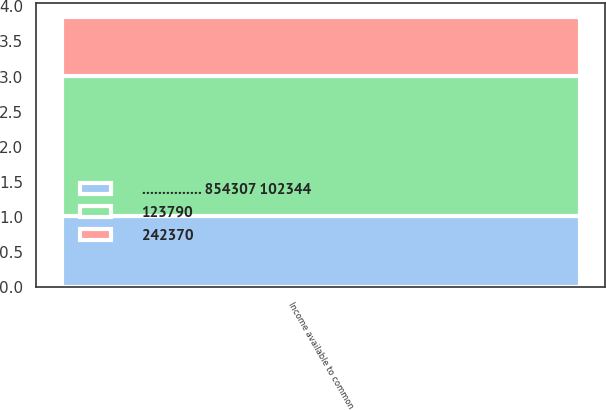Convert chart. <chart><loc_0><loc_0><loc_500><loc_500><stacked_bar_chart><ecel><fcel>Income available to common<nl><fcel>242370<fcel>0.84<nl><fcel>123790<fcel>1.99<nl><fcel>............... 854307 102344<fcel>1.02<nl></chart> 